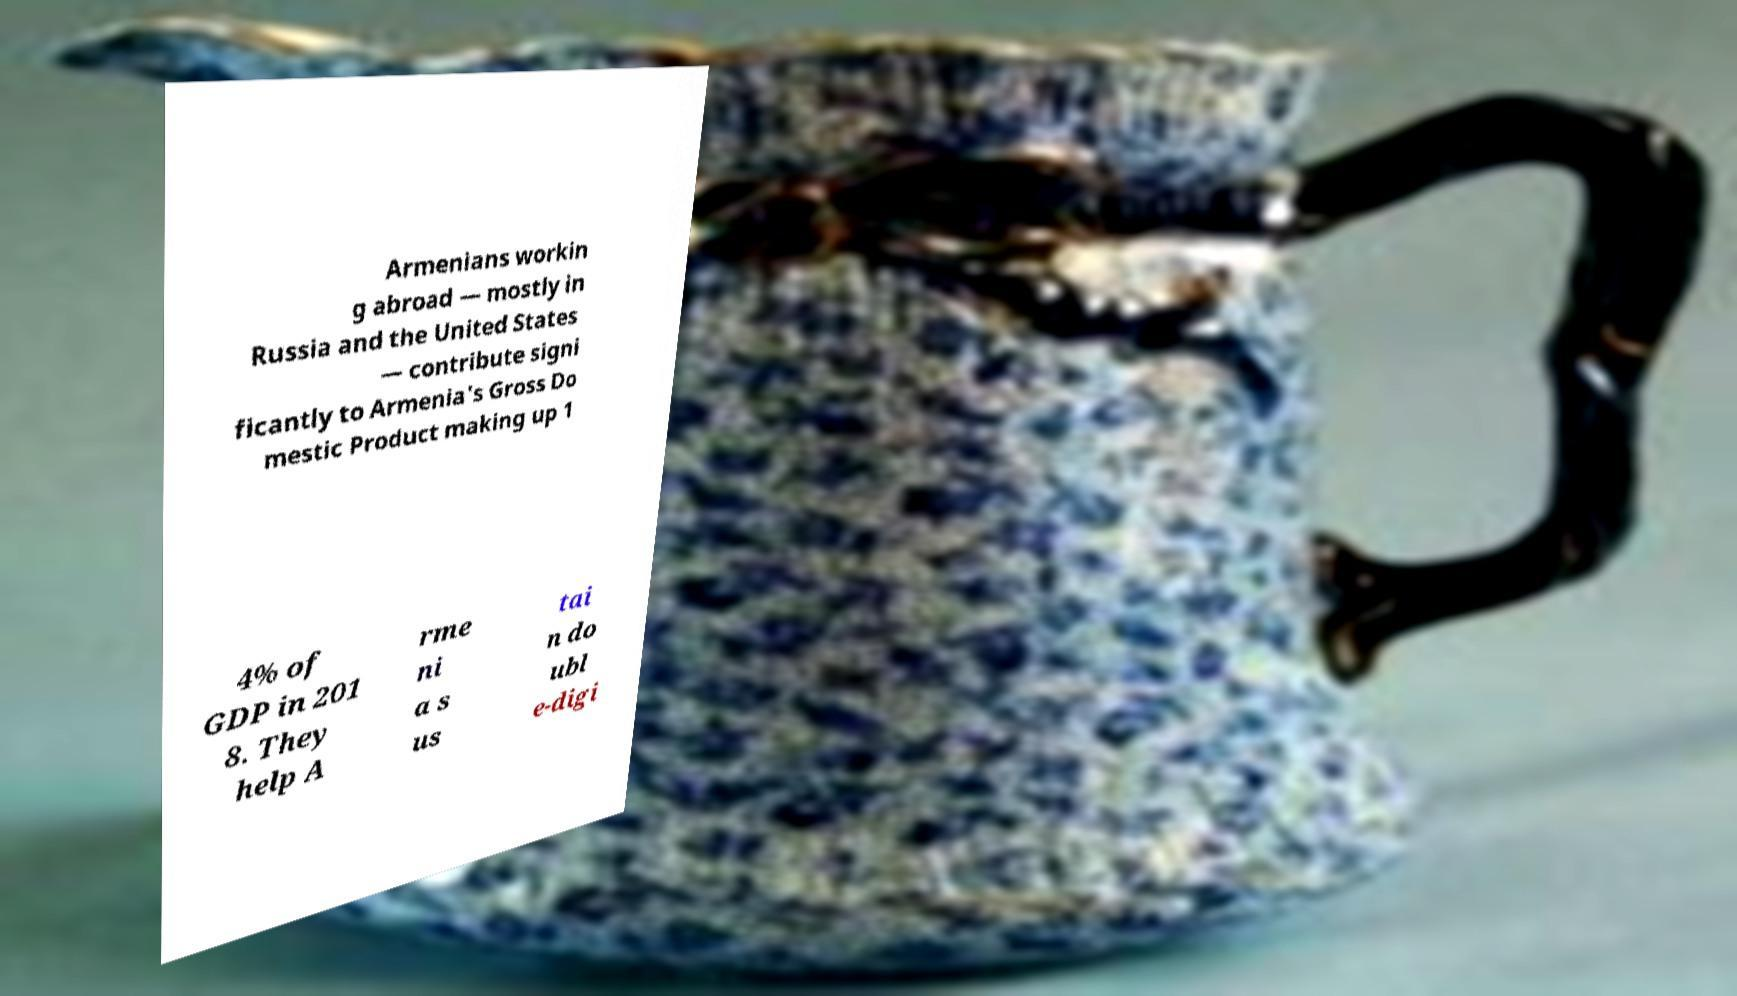For documentation purposes, I need the text within this image transcribed. Could you provide that? Armenians workin g abroad — mostly in Russia and the United States — contribute signi ficantly to Armenia's Gross Do mestic Product making up 1 4% of GDP in 201 8. They help A rme ni a s us tai n do ubl e-digi 